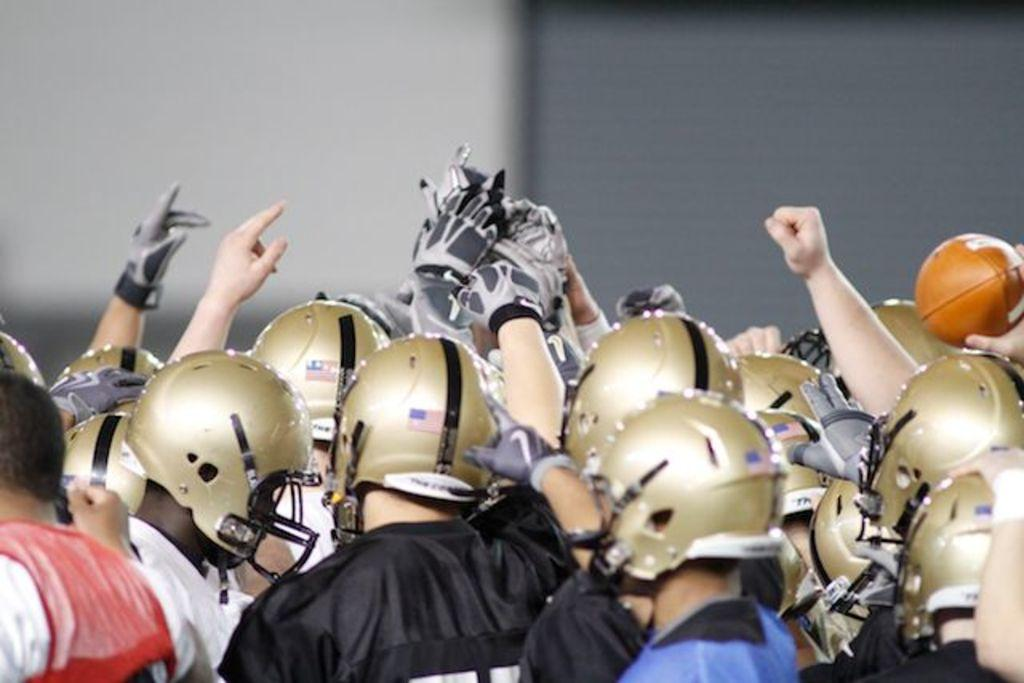Who or what can be seen in the image? There are people in the image. What are the people wearing on their heads? The people are wearing helmets. Where are the people located in the image? The people are located at the bottom of the image. What type of scissors can be seen in the image? There are no scissors present in the image. What kind of star is visible in the image? There is no star visible in the image. 